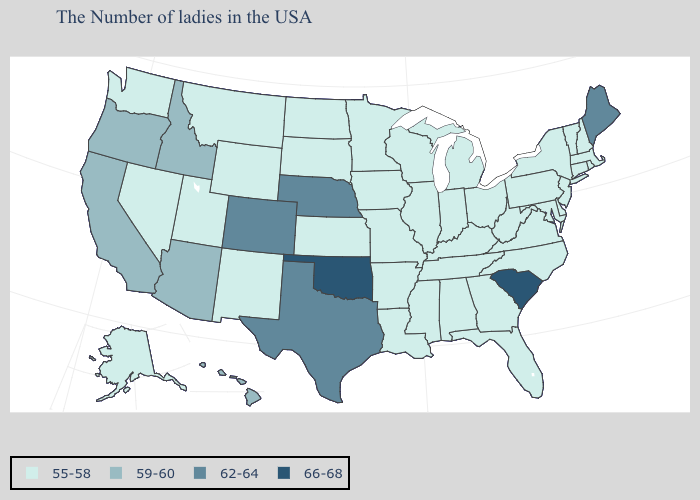Does Colorado have the highest value in the West?
Write a very short answer. Yes. Name the states that have a value in the range 55-58?
Short answer required. Massachusetts, Rhode Island, New Hampshire, Vermont, Connecticut, New York, New Jersey, Delaware, Maryland, Pennsylvania, Virginia, North Carolina, West Virginia, Ohio, Florida, Georgia, Michigan, Kentucky, Indiana, Alabama, Tennessee, Wisconsin, Illinois, Mississippi, Louisiana, Missouri, Arkansas, Minnesota, Iowa, Kansas, South Dakota, North Dakota, Wyoming, New Mexico, Utah, Montana, Nevada, Washington, Alaska. What is the value of Washington?
Concise answer only. 55-58. Name the states that have a value in the range 66-68?
Short answer required. South Carolina, Oklahoma. Does the first symbol in the legend represent the smallest category?
Answer briefly. Yes. Among the states that border Texas , does Arkansas have the highest value?
Short answer required. No. Name the states that have a value in the range 59-60?
Give a very brief answer. Arizona, Idaho, California, Oregon, Hawaii. What is the lowest value in the USA?
Keep it brief. 55-58. Name the states that have a value in the range 55-58?
Answer briefly. Massachusetts, Rhode Island, New Hampshire, Vermont, Connecticut, New York, New Jersey, Delaware, Maryland, Pennsylvania, Virginia, North Carolina, West Virginia, Ohio, Florida, Georgia, Michigan, Kentucky, Indiana, Alabama, Tennessee, Wisconsin, Illinois, Mississippi, Louisiana, Missouri, Arkansas, Minnesota, Iowa, Kansas, South Dakota, North Dakota, Wyoming, New Mexico, Utah, Montana, Nevada, Washington, Alaska. What is the highest value in the USA?
Answer briefly. 66-68. What is the value of Arkansas?
Give a very brief answer. 55-58. What is the value of Kentucky?
Short answer required. 55-58. What is the lowest value in the Northeast?
Concise answer only. 55-58. Does North Dakota have the lowest value in the MidWest?
Concise answer only. Yes. 